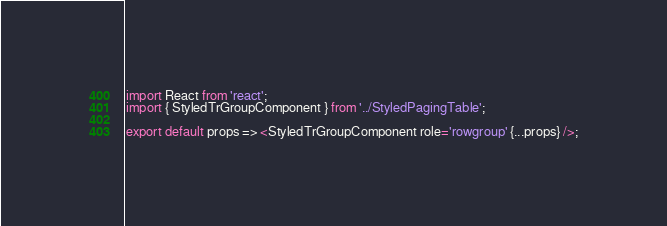<code> <loc_0><loc_0><loc_500><loc_500><_JavaScript_>import React from 'react';
import { StyledTrGroupComponent } from '../StyledPagingTable';

export default props => <StyledTrGroupComponent role='rowgroup' {...props} />;
</code> 